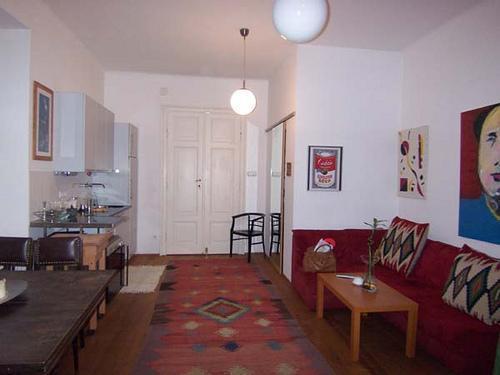How many people in this image are wearing a white jacket?
Give a very brief answer. 0. 